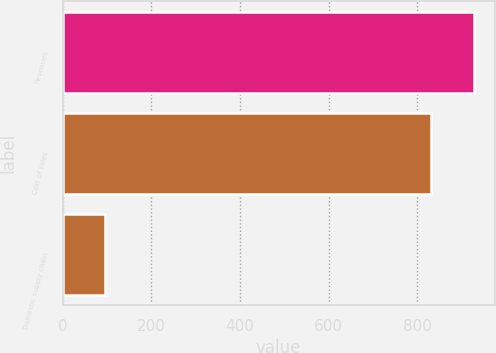<chart> <loc_0><loc_0><loc_500><loc_500><bar_chart><fcel>Revenues<fcel>Cost of sales<fcel>Domestic supply chain<nl><fcel>927.9<fcel>831.7<fcel>96.2<nl></chart> 